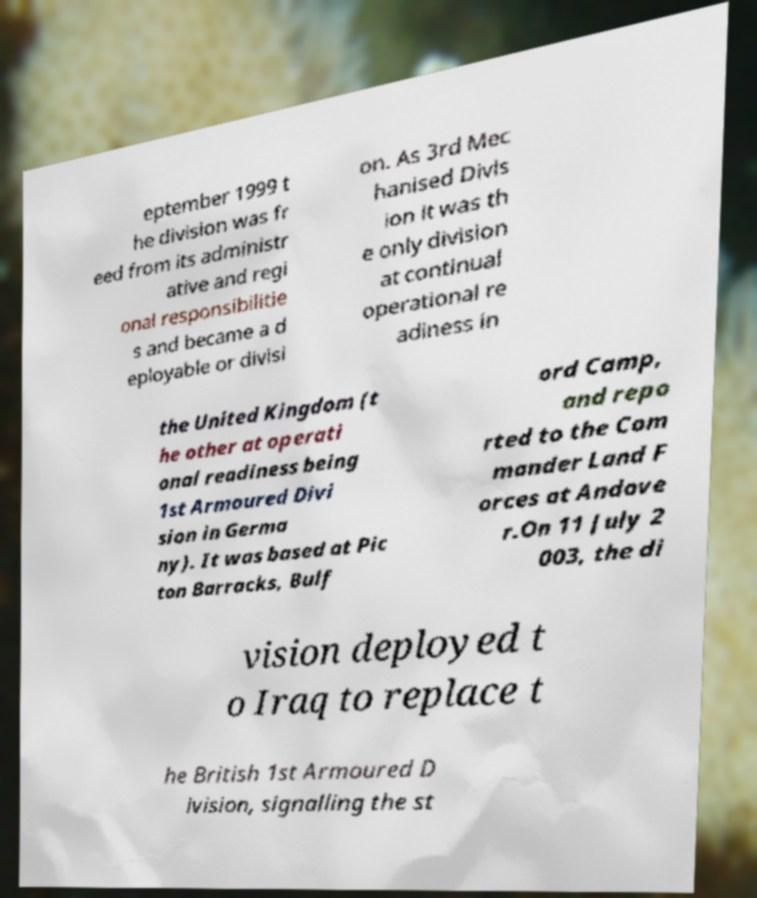Could you extract and type out the text from this image? eptember 1999 t he division was fr eed from its administr ative and regi onal responsibilitie s and became a d eployable or divisi on. As 3rd Mec hanised Divis ion it was th e only division at continual operational re adiness in the United Kingdom (t he other at operati onal readiness being 1st Armoured Divi sion in Germa ny). It was based at Pic ton Barracks, Bulf ord Camp, and repo rted to the Com mander Land F orces at Andove r.On 11 July 2 003, the di vision deployed t o Iraq to replace t he British 1st Armoured D ivision, signalling the st 